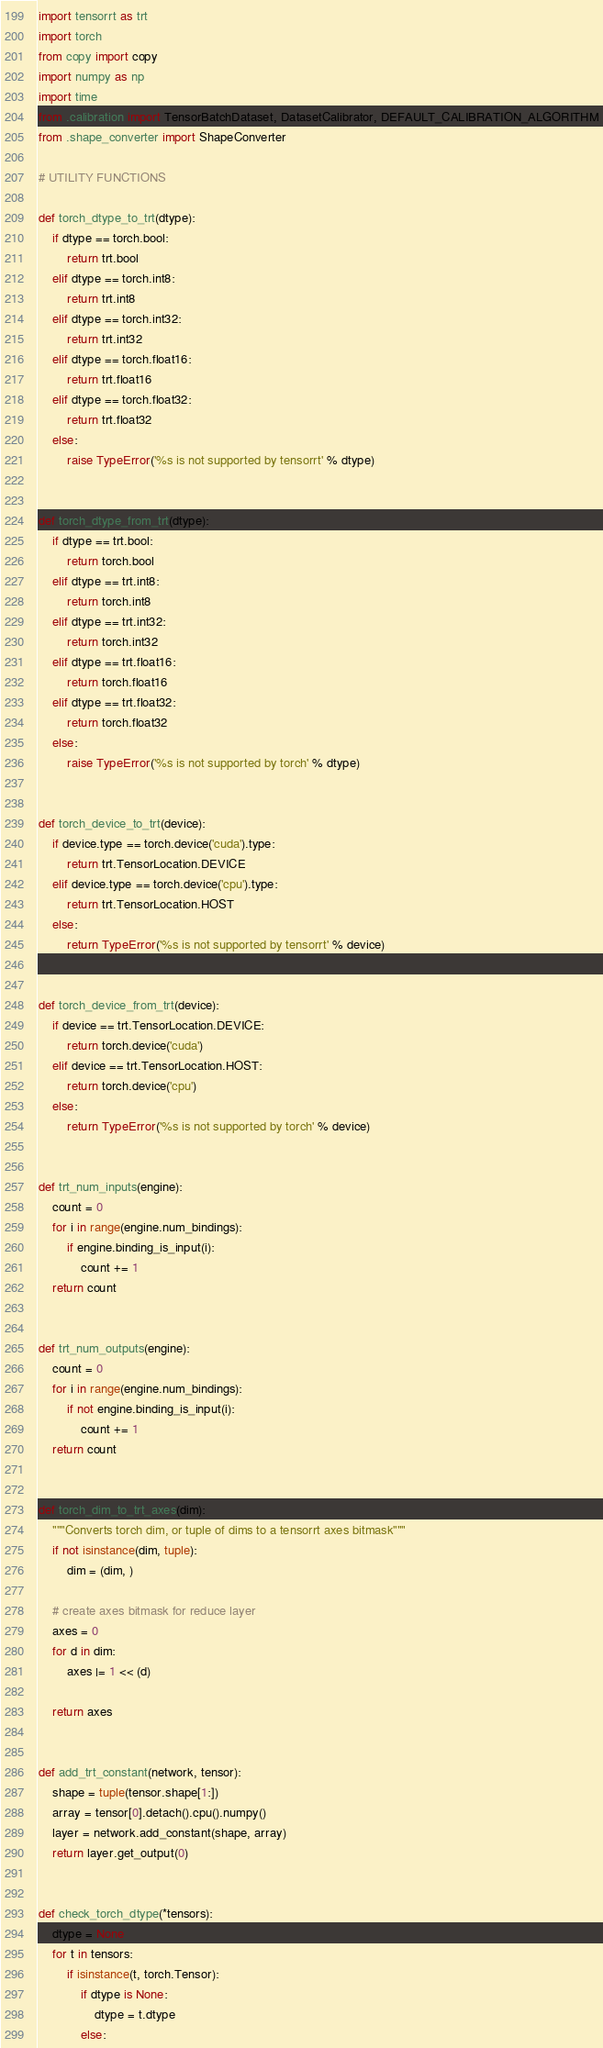<code> <loc_0><loc_0><loc_500><loc_500><_Python_>import tensorrt as trt
import torch
from copy import copy
import numpy as np
import time
from .calibration import TensorBatchDataset, DatasetCalibrator, DEFAULT_CALIBRATION_ALGORITHM
from .shape_converter import ShapeConverter

# UTILITY FUNCTIONS

def torch_dtype_to_trt(dtype):
    if dtype == torch.bool:
        return trt.bool
    elif dtype == torch.int8:
        return trt.int8
    elif dtype == torch.int32:
        return trt.int32
    elif dtype == torch.float16:
        return trt.float16
    elif dtype == torch.float32:
        return trt.float32
    else:
        raise TypeError('%s is not supported by tensorrt' % dtype)


def torch_dtype_from_trt(dtype):
    if dtype == trt.bool:
        return torch.bool
    elif dtype == trt.int8:
        return torch.int8
    elif dtype == trt.int32:
        return torch.int32
    elif dtype == trt.float16:
        return torch.float16
    elif dtype == trt.float32:
        return torch.float32
    else:
        raise TypeError('%s is not supported by torch' % dtype)


def torch_device_to_trt(device):
    if device.type == torch.device('cuda').type:
        return trt.TensorLocation.DEVICE
    elif device.type == torch.device('cpu').type:
        return trt.TensorLocation.HOST
    else:
        return TypeError('%s is not supported by tensorrt' % device)


def torch_device_from_trt(device):
    if device == trt.TensorLocation.DEVICE:
        return torch.device('cuda')
    elif device == trt.TensorLocation.HOST:
        return torch.device('cpu')
    else:
        return TypeError('%s is not supported by torch' % device)


def trt_num_inputs(engine):
    count = 0
    for i in range(engine.num_bindings):
        if engine.binding_is_input(i):
            count += 1
    return count


def trt_num_outputs(engine):
    count = 0
    for i in range(engine.num_bindings):
        if not engine.binding_is_input(i):
            count += 1
    return count


def torch_dim_to_trt_axes(dim):
    """Converts torch dim, or tuple of dims to a tensorrt axes bitmask"""
    if not isinstance(dim, tuple):
        dim = (dim, )

    # create axes bitmask for reduce layer
    axes = 0
    for d in dim:
        axes |= 1 << (d)

    return axes


def add_trt_constant(network, tensor):
    shape = tuple(tensor.shape[1:])
    array = tensor[0].detach().cpu().numpy()
    layer = network.add_constant(shape, array)
    return layer.get_output(0)


def check_torch_dtype(*tensors):
    dtype = None
    for t in tensors:
        if isinstance(t, torch.Tensor):
            if dtype is None:
                dtype = t.dtype
            else:</code> 